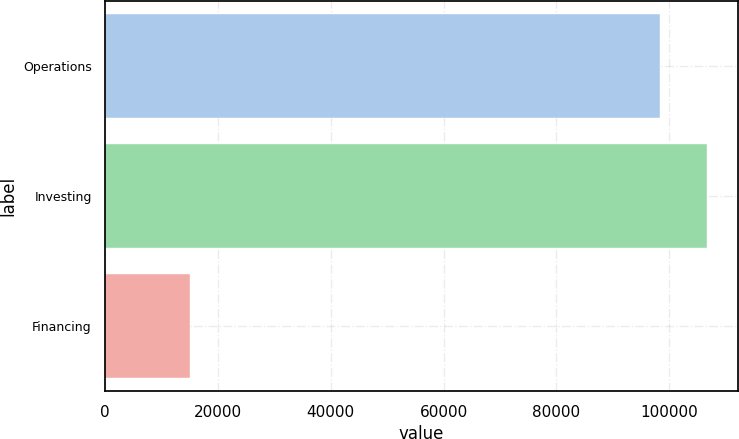Convert chart to OTSL. <chart><loc_0><loc_0><loc_500><loc_500><bar_chart><fcel>Operations<fcel>Investing<fcel>Financing<nl><fcel>98303<fcel>106781<fcel>15126<nl></chart> 